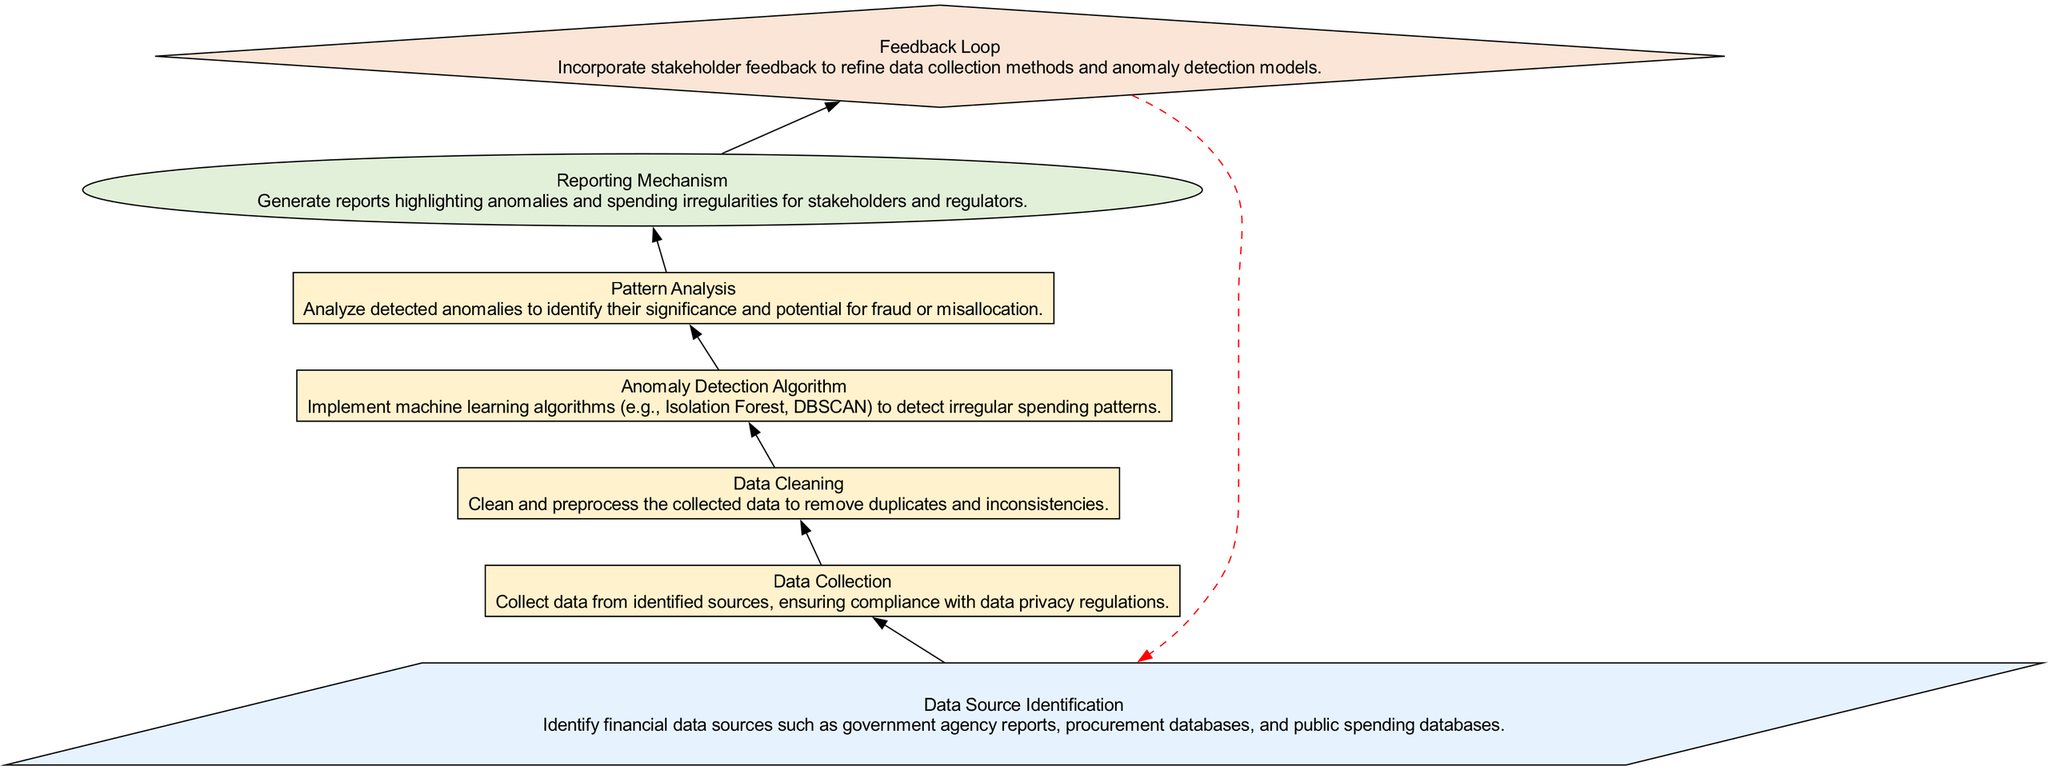What is the first step in the flow chart? The flow chart begins with the step labeled "Data Source Identification," which is the starting point of the process.
Answer: Data Source Identification How many total nodes are there in the diagram? By counting each step including input, processes, output, and feedback, there are a total of seven nodes in the diagram.
Answer: Seven Which node comes after "Data Cleaning"? Following "Data Cleaning," the next step in the process is "Anomaly Detection Algorithm," indicating the flow of the process.
Answer: Anomaly Detection Algorithm What type of node is "Reporting Mechanism"? "Reporting Mechanism" is categorized as an output type node that presents the results of the preceding analysis.
Answer: Output What color represents the process nodes in the diagram? The process nodes are filled with a light yellow color, indicating their role in the flow of the diagram.
Answer: Light yellow Which step indicates stakeholder engagement in the process? The step "Feedback Loop" is where stakeholder feedback is incorporated to improve methods and models, highlighting their engagement in the process.
Answer: Feedback Loop Which step precedes "Pattern Analysis"? The step "Anomaly Detection Algorithm" precedes "Pattern Analysis," showing the order of operations leading to the analysis stage.
Answer: Anomaly Detection Algorithm What is the significance of the dashed red arrow in the diagram? The dashed red arrow represents a feedback loop that connects the end of the process back to the beginning, emphasizing the iterative nature of data collection and anomaly detection.
Answer: Feedback loop What type of algorithm is mentioned in the "Anomaly Detection Algorithm" node? The "Anomaly Detection Algorithm" node mentions machine learning algorithms such as Isolation Forest and DBSCAN for detecting anomalies.
Answer: Machine learning algorithms 